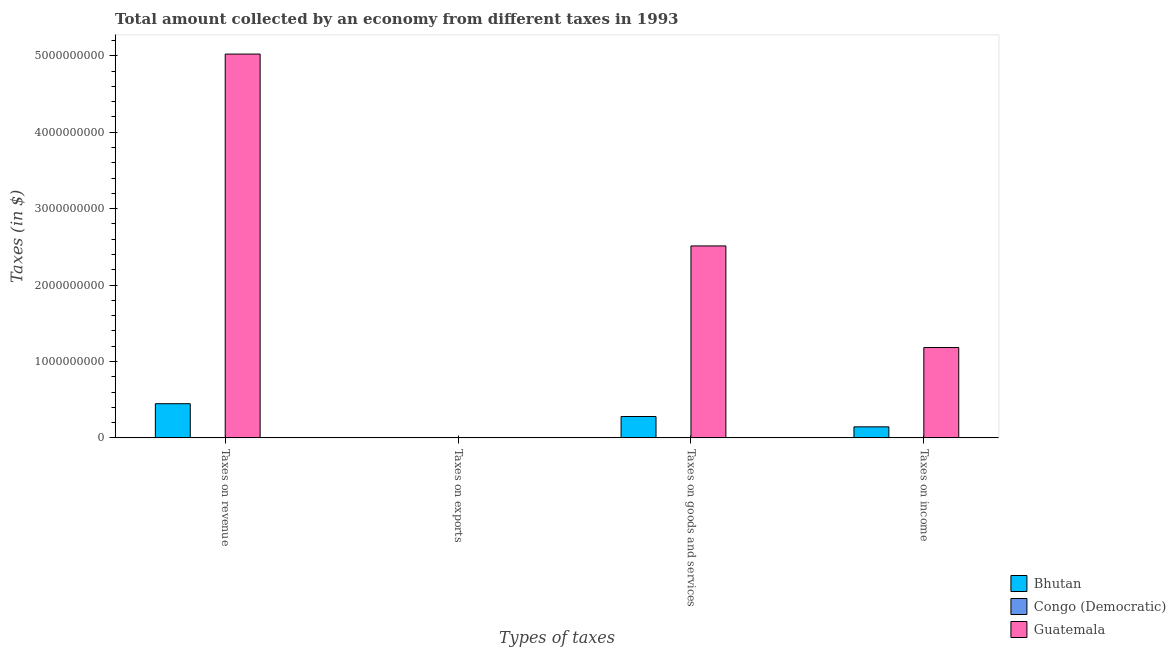How many groups of bars are there?
Make the answer very short. 4. Are the number of bars on each tick of the X-axis equal?
Make the answer very short. Yes. How many bars are there on the 1st tick from the left?
Ensure brevity in your answer.  3. How many bars are there on the 2nd tick from the right?
Offer a very short reply. 3. What is the label of the 2nd group of bars from the left?
Give a very brief answer. Taxes on exports. What is the amount collected as tax on goods in Bhutan?
Give a very brief answer. 2.80e+08. Across all countries, what is the maximum amount collected as tax on exports?
Your answer should be very brief. 1.60e+06. Across all countries, what is the minimum amount collected as tax on goods?
Your response must be concise. 2648.76. In which country was the amount collected as tax on revenue maximum?
Your answer should be very brief. Guatemala. In which country was the amount collected as tax on exports minimum?
Your answer should be very brief. Congo (Democratic). What is the total amount collected as tax on revenue in the graph?
Your answer should be very brief. 5.47e+09. What is the difference between the amount collected as tax on income in Guatemala and that in Bhutan?
Provide a short and direct response. 1.04e+09. What is the difference between the amount collected as tax on income in Bhutan and the amount collected as tax on exports in Guatemala?
Offer a very short reply. 1.44e+08. What is the average amount collected as tax on exports per country?
Your answer should be compact. 5.37e+05. What is the difference between the amount collected as tax on goods and amount collected as tax on income in Congo (Democratic)?
Ensure brevity in your answer.  -168.52. In how many countries, is the amount collected as tax on income greater than 1800000000 $?
Provide a short and direct response. 0. What is the ratio of the amount collected as tax on revenue in Guatemala to that in Bhutan?
Ensure brevity in your answer.  11.24. Is the amount collected as tax on revenue in Bhutan less than that in Guatemala?
Offer a terse response. Yes. What is the difference between the highest and the second highest amount collected as tax on exports?
Provide a short and direct response. 1.59e+06. What is the difference between the highest and the lowest amount collected as tax on income?
Keep it short and to the point. 1.18e+09. Is the sum of the amount collected as tax on exports in Guatemala and Congo (Democratic) greater than the maximum amount collected as tax on goods across all countries?
Ensure brevity in your answer.  No. What does the 2nd bar from the left in Taxes on goods and services represents?
Provide a succinct answer. Congo (Democratic). What does the 3rd bar from the right in Taxes on revenue represents?
Your answer should be compact. Bhutan. Are the values on the major ticks of Y-axis written in scientific E-notation?
Provide a succinct answer. No. Does the graph contain grids?
Offer a terse response. No. Where does the legend appear in the graph?
Make the answer very short. Bottom right. How many legend labels are there?
Your response must be concise. 3. What is the title of the graph?
Offer a terse response. Total amount collected by an economy from different taxes in 1993. What is the label or title of the X-axis?
Make the answer very short. Types of taxes. What is the label or title of the Y-axis?
Provide a succinct answer. Taxes (in $). What is the Taxes (in $) of Bhutan in Taxes on revenue?
Your answer should be very brief. 4.47e+08. What is the Taxes (in $) in Congo (Democratic) in Taxes on revenue?
Your answer should be compact. 9174.58. What is the Taxes (in $) in Guatemala in Taxes on revenue?
Provide a short and direct response. 5.02e+09. What is the Taxes (in $) in Bhutan in Taxes on exports?
Offer a very short reply. 1.60e+06. What is the Taxes (in $) in Congo (Democratic) in Taxes on exports?
Your answer should be very brief. 1143.63. What is the Taxes (in $) of Guatemala in Taxes on exports?
Provide a short and direct response. 10000. What is the Taxes (in $) in Bhutan in Taxes on goods and services?
Your answer should be very brief. 2.80e+08. What is the Taxes (in $) of Congo (Democratic) in Taxes on goods and services?
Your answer should be very brief. 2648.76. What is the Taxes (in $) in Guatemala in Taxes on goods and services?
Your answer should be very brief. 2.51e+09. What is the Taxes (in $) of Bhutan in Taxes on income?
Give a very brief answer. 1.44e+08. What is the Taxes (in $) of Congo (Democratic) in Taxes on income?
Provide a short and direct response. 2817.29. What is the Taxes (in $) of Guatemala in Taxes on income?
Your response must be concise. 1.18e+09. Across all Types of taxes, what is the maximum Taxes (in $) in Bhutan?
Provide a succinct answer. 4.47e+08. Across all Types of taxes, what is the maximum Taxes (in $) of Congo (Democratic)?
Provide a succinct answer. 9174.58. Across all Types of taxes, what is the maximum Taxes (in $) in Guatemala?
Make the answer very short. 5.02e+09. Across all Types of taxes, what is the minimum Taxes (in $) of Bhutan?
Ensure brevity in your answer.  1.60e+06. Across all Types of taxes, what is the minimum Taxes (in $) of Congo (Democratic)?
Keep it short and to the point. 1143.63. Across all Types of taxes, what is the minimum Taxes (in $) in Guatemala?
Your answer should be compact. 10000. What is the total Taxes (in $) in Bhutan in the graph?
Make the answer very short. 8.72e+08. What is the total Taxes (in $) of Congo (Democratic) in the graph?
Ensure brevity in your answer.  1.58e+04. What is the total Taxes (in $) in Guatemala in the graph?
Provide a succinct answer. 8.72e+09. What is the difference between the Taxes (in $) in Bhutan in Taxes on revenue and that in Taxes on exports?
Your answer should be very brief. 4.46e+08. What is the difference between the Taxes (in $) of Congo (Democratic) in Taxes on revenue and that in Taxes on exports?
Your response must be concise. 8030.95. What is the difference between the Taxes (in $) of Guatemala in Taxes on revenue and that in Taxes on exports?
Your response must be concise. 5.02e+09. What is the difference between the Taxes (in $) of Bhutan in Taxes on revenue and that in Taxes on goods and services?
Make the answer very short. 1.68e+08. What is the difference between the Taxes (in $) of Congo (Democratic) in Taxes on revenue and that in Taxes on goods and services?
Ensure brevity in your answer.  6525.81. What is the difference between the Taxes (in $) of Guatemala in Taxes on revenue and that in Taxes on goods and services?
Provide a short and direct response. 2.51e+09. What is the difference between the Taxes (in $) of Bhutan in Taxes on revenue and that in Taxes on income?
Your response must be concise. 3.03e+08. What is the difference between the Taxes (in $) in Congo (Democratic) in Taxes on revenue and that in Taxes on income?
Keep it short and to the point. 6357.29. What is the difference between the Taxes (in $) in Guatemala in Taxes on revenue and that in Taxes on income?
Offer a terse response. 3.84e+09. What is the difference between the Taxes (in $) in Bhutan in Taxes on exports and that in Taxes on goods and services?
Ensure brevity in your answer.  -2.78e+08. What is the difference between the Taxes (in $) in Congo (Democratic) in Taxes on exports and that in Taxes on goods and services?
Your response must be concise. -1505.14. What is the difference between the Taxes (in $) of Guatemala in Taxes on exports and that in Taxes on goods and services?
Keep it short and to the point. -2.51e+09. What is the difference between the Taxes (in $) in Bhutan in Taxes on exports and that in Taxes on income?
Your response must be concise. -1.43e+08. What is the difference between the Taxes (in $) of Congo (Democratic) in Taxes on exports and that in Taxes on income?
Give a very brief answer. -1673.66. What is the difference between the Taxes (in $) in Guatemala in Taxes on exports and that in Taxes on income?
Make the answer very short. -1.18e+09. What is the difference between the Taxes (in $) in Bhutan in Taxes on goods and services and that in Taxes on income?
Your response must be concise. 1.35e+08. What is the difference between the Taxes (in $) in Congo (Democratic) in Taxes on goods and services and that in Taxes on income?
Ensure brevity in your answer.  -168.52. What is the difference between the Taxes (in $) of Guatemala in Taxes on goods and services and that in Taxes on income?
Provide a succinct answer. 1.33e+09. What is the difference between the Taxes (in $) of Bhutan in Taxes on revenue and the Taxes (in $) of Congo (Democratic) in Taxes on exports?
Offer a terse response. 4.47e+08. What is the difference between the Taxes (in $) of Bhutan in Taxes on revenue and the Taxes (in $) of Guatemala in Taxes on exports?
Offer a very short reply. 4.47e+08. What is the difference between the Taxes (in $) of Congo (Democratic) in Taxes on revenue and the Taxes (in $) of Guatemala in Taxes on exports?
Your answer should be very brief. -825.42. What is the difference between the Taxes (in $) of Bhutan in Taxes on revenue and the Taxes (in $) of Congo (Democratic) in Taxes on goods and services?
Keep it short and to the point. 4.47e+08. What is the difference between the Taxes (in $) in Bhutan in Taxes on revenue and the Taxes (in $) in Guatemala in Taxes on goods and services?
Your response must be concise. -2.07e+09. What is the difference between the Taxes (in $) of Congo (Democratic) in Taxes on revenue and the Taxes (in $) of Guatemala in Taxes on goods and services?
Give a very brief answer. -2.51e+09. What is the difference between the Taxes (in $) of Bhutan in Taxes on revenue and the Taxes (in $) of Congo (Democratic) in Taxes on income?
Ensure brevity in your answer.  4.47e+08. What is the difference between the Taxes (in $) in Bhutan in Taxes on revenue and the Taxes (in $) in Guatemala in Taxes on income?
Provide a short and direct response. -7.35e+08. What is the difference between the Taxes (in $) of Congo (Democratic) in Taxes on revenue and the Taxes (in $) of Guatemala in Taxes on income?
Your response must be concise. -1.18e+09. What is the difference between the Taxes (in $) in Bhutan in Taxes on exports and the Taxes (in $) in Congo (Democratic) in Taxes on goods and services?
Provide a succinct answer. 1.60e+06. What is the difference between the Taxes (in $) in Bhutan in Taxes on exports and the Taxes (in $) in Guatemala in Taxes on goods and services?
Offer a very short reply. -2.51e+09. What is the difference between the Taxes (in $) of Congo (Democratic) in Taxes on exports and the Taxes (in $) of Guatemala in Taxes on goods and services?
Give a very brief answer. -2.51e+09. What is the difference between the Taxes (in $) in Bhutan in Taxes on exports and the Taxes (in $) in Congo (Democratic) in Taxes on income?
Offer a very short reply. 1.60e+06. What is the difference between the Taxes (in $) in Bhutan in Taxes on exports and the Taxes (in $) in Guatemala in Taxes on income?
Provide a succinct answer. -1.18e+09. What is the difference between the Taxes (in $) in Congo (Democratic) in Taxes on exports and the Taxes (in $) in Guatemala in Taxes on income?
Ensure brevity in your answer.  -1.18e+09. What is the difference between the Taxes (in $) of Bhutan in Taxes on goods and services and the Taxes (in $) of Congo (Democratic) in Taxes on income?
Offer a very short reply. 2.80e+08. What is the difference between the Taxes (in $) in Bhutan in Taxes on goods and services and the Taxes (in $) in Guatemala in Taxes on income?
Keep it short and to the point. -9.03e+08. What is the difference between the Taxes (in $) in Congo (Democratic) in Taxes on goods and services and the Taxes (in $) in Guatemala in Taxes on income?
Make the answer very short. -1.18e+09. What is the average Taxes (in $) in Bhutan per Types of taxes?
Offer a terse response. 2.18e+08. What is the average Taxes (in $) of Congo (Democratic) per Types of taxes?
Give a very brief answer. 3946.06. What is the average Taxes (in $) of Guatemala per Types of taxes?
Give a very brief answer. 2.18e+09. What is the difference between the Taxes (in $) of Bhutan and Taxes (in $) of Congo (Democratic) in Taxes on revenue?
Give a very brief answer. 4.47e+08. What is the difference between the Taxes (in $) of Bhutan and Taxes (in $) of Guatemala in Taxes on revenue?
Your answer should be compact. -4.58e+09. What is the difference between the Taxes (in $) in Congo (Democratic) and Taxes (in $) in Guatemala in Taxes on revenue?
Offer a very short reply. -5.02e+09. What is the difference between the Taxes (in $) in Bhutan and Taxes (in $) in Congo (Democratic) in Taxes on exports?
Ensure brevity in your answer.  1.60e+06. What is the difference between the Taxes (in $) of Bhutan and Taxes (in $) of Guatemala in Taxes on exports?
Give a very brief answer. 1.59e+06. What is the difference between the Taxes (in $) in Congo (Democratic) and Taxes (in $) in Guatemala in Taxes on exports?
Make the answer very short. -8856.37. What is the difference between the Taxes (in $) of Bhutan and Taxes (in $) of Congo (Democratic) in Taxes on goods and services?
Give a very brief answer. 2.80e+08. What is the difference between the Taxes (in $) in Bhutan and Taxes (in $) in Guatemala in Taxes on goods and services?
Ensure brevity in your answer.  -2.23e+09. What is the difference between the Taxes (in $) of Congo (Democratic) and Taxes (in $) of Guatemala in Taxes on goods and services?
Ensure brevity in your answer.  -2.51e+09. What is the difference between the Taxes (in $) in Bhutan and Taxes (in $) in Congo (Democratic) in Taxes on income?
Your response must be concise. 1.44e+08. What is the difference between the Taxes (in $) of Bhutan and Taxes (in $) of Guatemala in Taxes on income?
Provide a short and direct response. -1.04e+09. What is the difference between the Taxes (in $) in Congo (Democratic) and Taxes (in $) in Guatemala in Taxes on income?
Your answer should be compact. -1.18e+09. What is the ratio of the Taxes (in $) of Bhutan in Taxes on revenue to that in Taxes on exports?
Make the answer very short. 279.44. What is the ratio of the Taxes (in $) in Congo (Democratic) in Taxes on revenue to that in Taxes on exports?
Your answer should be compact. 8.02. What is the ratio of the Taxes (in $) of Guatemala in Taxes on revenue to that in Taxes on exports?
Make the answer very short. 5.02e+05. What is the ratio of the Taxes (in $) of Bhutan in Taxes on revenue to that in Taxes on goods and services?
Make the answer very short. 1.6. What is the ratio of the Taxes (in $) in Congo (Democratic) in Taxes on revenue to that in Taxes on goods and services?
Your answer should be very brief. 3.46. What is the ratio of the Taxes (in $) of Guatemala in Taxes on revenue to that in Taxes on goods and services?
Your answer should be compact. 2. What is the ratio of the Taxes (in $) of Bhutan in Taxes on revenue to that in Taxes on income?
Your answer should be compact. 3.1. What is the ratio of the Taxes (in $) of Congo (Democratic) in Taxes on revenue to that in Taxes on income?
Make the answer very short. 3.26. What is the ratio of the Taxes (in $) in Guatemala in Taxes on revenue to that in Taxes on income?
Your answer should be compact. 4.25. What is the ratio of the Taxes (in $) in Bhutan in Taxes on exports to that in Taxes on goods and services?
Provide a short and direct response. 0.01. What is the ratio of the Taxes (in $) in Congo (Democratic) in Taxes on exports to that in Taxes on goods and services?
Your response must be concise. 0.43. What is the ratio of the Taxes (in $) in Guatemala in Taxes on exports to that in Taxes on goods and services?
Provide a short and direct response. 0. What is the ratio of the Taxes (in $) of Bhutan in Taxes on exports to that in Taxes on income?
Offer a terse response. 0.01. What is the ratio of the Taxes (in $) of Congo (Democratic) in Taxes on exports to that in Taxes on income?
Keep it short and to the point. 0.41. What is the ratio of the Taxes (in $) in Bhutan in Taxes on goods and services to that in Taxes on income?
Your response must be concise. 1.94. What is the ratio of the Taxes (in $) of Congo (Democratic) in Taxes on goods and services to that in Taxes on income?
Your response must be concise. 0.94. What is the ratio of the Taxes (in $) of Guatemala in Taxes on goods and services to that in Taxes on income?
Make the answer very short. 2.12. What is the difference between the highest and the second highest Taxes (in $) in Bhutan?
Offer a very short reply. 1.68e+08. What is the difference between the highest and the second highest Taxes (in $) in Congo (Democratic)?
Your answer should be compact. 6357.29. What is the difference between the highest and the second highest Taxes (in $) of Guatemala?
Keep it short and to the point. 2.51e+09. What is the difference between the highest and the lowest Taxes (in $) of Bhutan?
Your answer should be compact. 4.46e+08. What is the difference between the highest and the lowest Taxes (in $) in Congo (Democratic)?
Give a very brief answer. 8030.95. What is the difference between the highest and the lowest Taxes (in $) of Guatemala?
Give a very brief answer. 5.02e+09. 